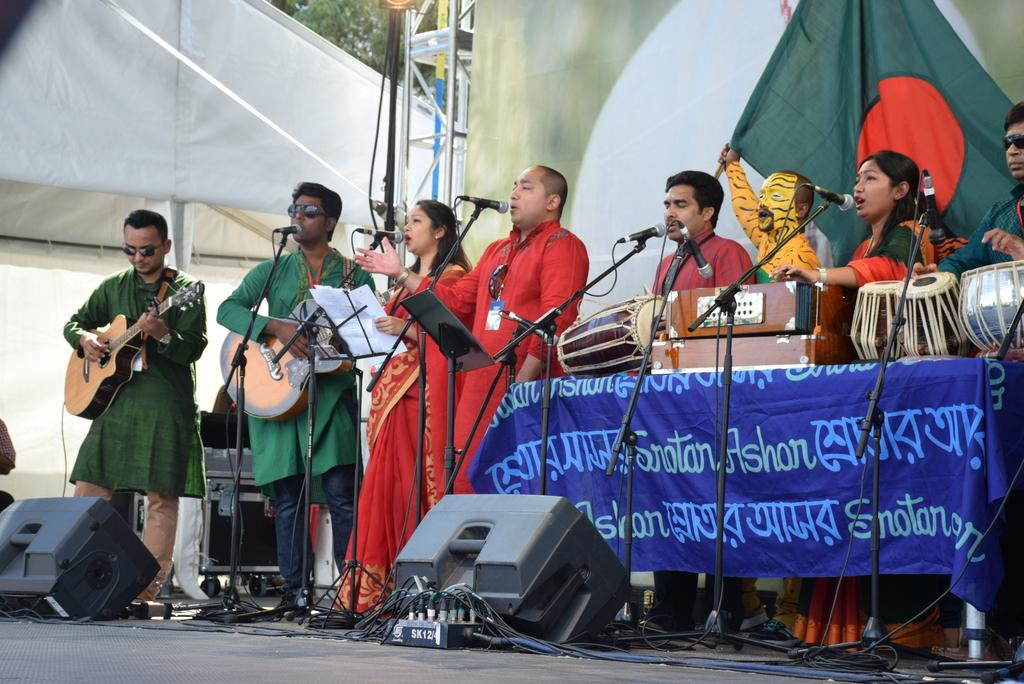What are the people on the stage doing? The people on the stage are performing. What activity are they engaged in while performing? They are playing musical instruments. What can be seen in the background behind the performers? There is a pole, a banner, and a tree in the background. Can you tell me how deep the river is in the image? There is no river present in the image. What is the temper of the performers on stage? The provided facts do not give any information about the performers' temper, so we cannot determine their temper from the image. 